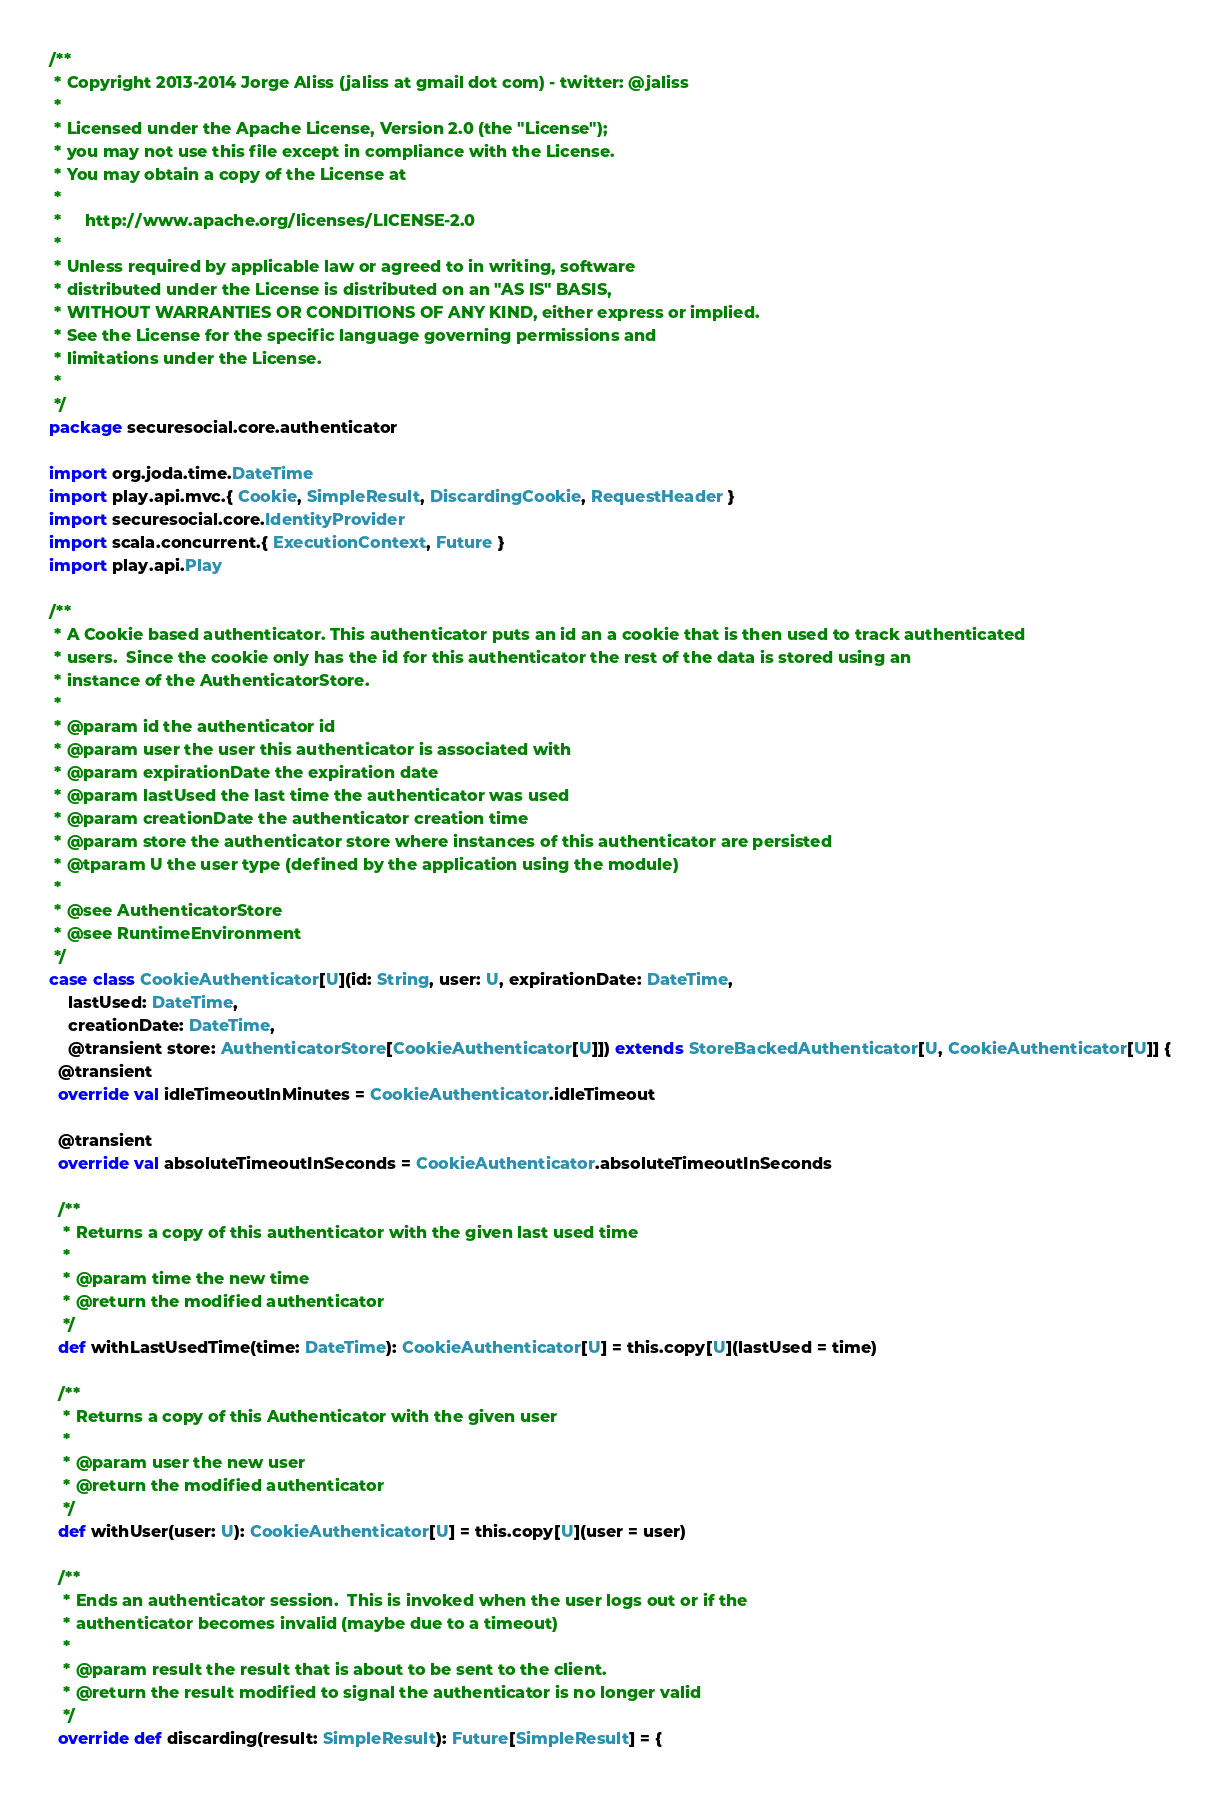Convert code to text. <code><loc_0><loc_0><loc_500><loc_500><_Scala_>/**
 * Copyright 2013-2014 Jorge Aliss (jaliss at gmail dot com) - twitter: @jaliss
 *
 * Licensed under the Apache License, Version 2.0 (the "License");
 * you may not use this file except in compliance with the License.
 * You may obtain a copy of the License at
 *
 *     http://www.apache.org/licenses/LICENSE-2.0
 *
 * Unless required by applicable law or agreed to in writing, software
 * distributed under the License is distributed on an "AS IS" BASIS,
 * WITHOUT WARRANTIES OR CONDITIONS OF ANY KIND, either express or implied.
 * See the License for the specific language governing permissions and
 * limitations under the License.
 *
 */
package securesocial.core.authenticator

import org.joda.time.DateTime
import play.api.mvc.{ Cookie, SimpleResult, DiscardingCookie, RequestHeader }
import securesocial.core.IdentityProvider
import scala.concurrent.{ ExecutionContext, Future }
import play.api.Play

/**
 * A Cookie based authenticator. This authenticator puts an id an a cookie that is then used to track authenticated
 * users.  Since the cookie only has the id for this authenticator the rest of the data is stored using an
 * instance of the AuthenticatorStore.
 *
 * @param id the authenticator id
 * @param user the user this authenticator is associated with
 * @param expirationDate the expiration date
 * @param lastUsed the last time the authenticator was used
 * @param creationDate the authenticator creation time
 * @param store the authenticator store where instances of this authenticator are persisted
 * @tparam U the user type (defined by the application using the module)
 *
 * @see AuthenticatorStore
 * @see RuntimeEnvironment
 */
case class CookieAuthenticator[U](id: String, user: U, expirationDate: DateTime,
    lastUsed: DateTime,
    creationDate: DateTime,
    @transient store: AuthenticatorStore[CookieAuthenticator[U]]) extends StoreBackedAuthenticator[U, CookieAuthenticator[U]] {
  @transient
  override val idleTimeoutInMinutes = CookieAuthenticator.idleTimeout

  @transient
  override val absoluteTimeoutInSeconds = CookieAuthenticator.absoluteTimeoutInSeconds

  /**
   * Returns a copy of this authenticator with the given last used time
   *
   * @param time the new time
   * @return the modified authenticator
   */
  def withLastUsedTime(time: DateTime): CookieAuthenticator[U] = this.copy[U](lastUsed = time)

  /**
   * Returns a copy of this Authenticator with the given user
   *
   * @param user the new user
   * @return the modified authenticator
   */
  def withUser(user: U): CookieAuthenticator[U] = this.copy[U](user = user)

  /**
   * Ends an authenticator session.  This is invoked when the user logs out or if the
   * authenticator becomes invalid (maybe due to a timeout)
   *
   * @param result the result that is about to be sent to the client.
   * @return the result modified to signal the authenticator is no longer valid
   */
  override def discarding(result: SimpleResult): Future[SimpleResult] = {</code> 